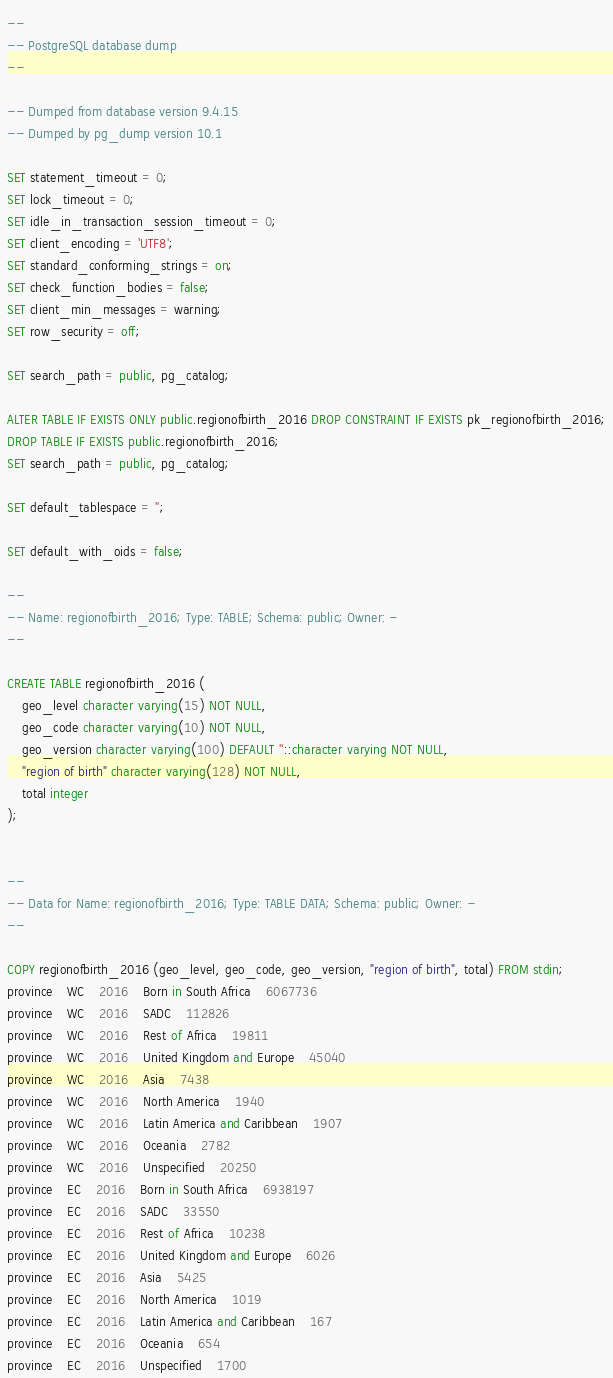Convert code to text. <code><loc_0><loc_0><loc_500><loc_500><_SQL_>--
-- PostgreSQL database dump
--

-- Dumped from database version 9.4.15
-- Dumped by pg_dump version 10.1

SET statement_timeout = 0;
SET lock_timeout = 0;
SET idle_in_transaction_session_timeout = 0;
SET client_encoding = 'UTF8';
SET standard_conforming_strings = on;
SET check_function_bodies = false;
SET client_min_messages = warning;
SET row_security = off;

SET search_path = public, pg_catalog;

ALTER TABLE IF EXISTS ONLY public.regionofbirth_2016 DROP CONSTRAINT IF EXISTS pk_regionofbirth_2016;
DROP TABLE IF EXISTS public.regionofbirth_2016;
SET search_path = public, pg_catalog;

SET default_tablespace = '';

SET default_with_oids = false;

--
-- Name: regionofbirth_2016; Type: TABLE; Schema: public; Owner: -
--

CREATE TABLE regionofbirth_2016 (
    geo_level character varying(15) NOT NULL,
    geo_code character varying(10) NOT NULL,
    geo_version character varying(100) DEFAULT ''::character varying NOT NULL,
    "region of birth" character varying(128) NOT NULL,
    total integer
);


--
-- Data for Name: regionofbirth_2016; Type: TABLE DATA; Schema: public; Owner: -
--

COPY regionofbirth_2016 (geo_level, geo_code, geo_version, "region of birth", total) FROM stdin;
province	WC	2016	Born in South Africa	6067736
province	WC	2016	SADC	112826
province	WC	2016	Rest of Africa	19811
province	WC	2016	United Kingdom and Europe	45040
province	WC	2016	Asia	7438
province	WC	2016	North America	1940
province	WC	2016	Latin America and Caribbean	1907
province	WC	2016	Oceania	2782
province	WC	2016	Unspecified	20250
province	EC	2016	Born in South Africa	6938197
province	EC	2016	SADC	33550
province	EC	2016	Rest of Africa	10238
province	EC	2016	United Kingdom and Europe	6026
province	EC	2016	Asia	5425
province	EC	2016	North America	1019
province	EC	2016	Latin America and Caribbean	167
province	EC	2016	Oceania	654
province	EC	2016	Unspecified	1700</code> 